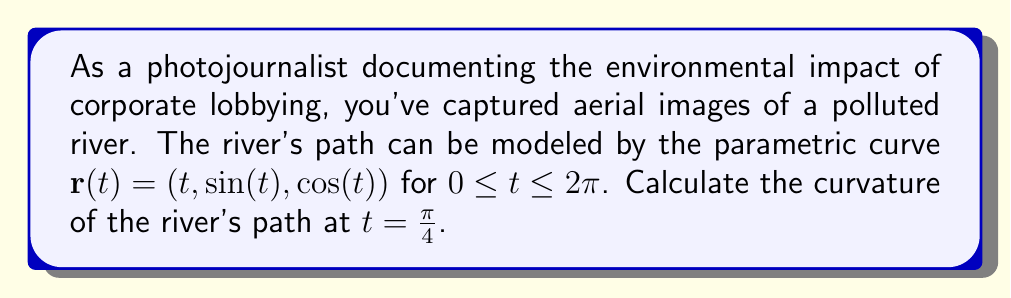Teach me how to tackle this problem. To calculate the curvature of the river's path, we'll use the formula for the curvature of a parametric curve in 3D space:

$$\kappa = \frac{|\mathbf{r}'(t) \times \mathbf{r}''(t)|}{|\mathbf{r}'(t)|^3}$$

Step 1: Calculate $\mathbf{r}'(t)$
$$\mathbf{r}'(t) = (1, \cos(t), -\sin(t))$$

Step 2: Calculate $\mathbf{r}''(t)$
$$\mathbf{r}''(t) = (0, -\sin(t), -\cos(t))$$

Step 3: Calculate $\mathbf{r}'(t) \times \mathbf{r}''(t)$
$$\begin{align*}
\mathbf{r}'(t) \times \mathbf{r}''(t) &= \begin{vmatrix}
\mathbf{i} & \mathbf{j} & \mathbf{k} \\
1 & \cos(t) & -\sin(t) \\
0 & -\sin(t) & -\cos(t)
\end{vmatrix} \\
&= (-\cos^2(t) - \sin^2(t), \sin(t), \cos(t)) \\
&= (-1, \sin(t), \cos(t))
\end{align*}$$

Step 4: Calculate $|\mathbf{r}'(t) \times \mathbf{r}''(t)|$
$$|\mathbf{r}'(t) \times \mathbf{r}''(t)| = \sqrt{(-1)^2 + \sin^2(t) + \cos^2(t)} = \sqrt{2}$$

Step 5: Calculate $|\mathbf{r}'(t)|$
$$|\mathbf{r}'(t)| = \sqrt{1^2 + \cos^2(t) + \sin^2(t)} = \sqrt{2}$$

Step 6: Apply the curvature formula at $t = \frac{\pi}{4}$
$$\kappa = \frac{|\mathbf{r}'(t) \times \mathbf{r}''(t)|}{|\mathbf{r}'(t)|^3} = \frac{\sqrt{2}}{(\sqrt{2})^3} = \frac{\sqrt{2}}{2\sqrt{2}} = \frac{1}{2}$$
Answer: $\frac{1}{2}$ 